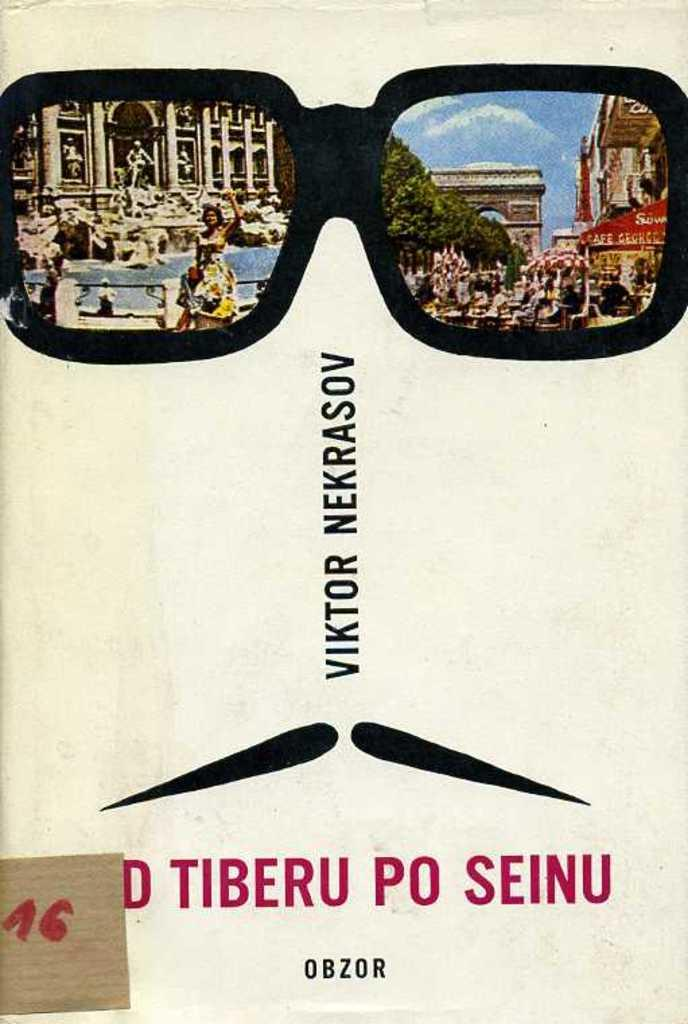Who is the person in the image? Bernard Cribbins is in the image. What type of snow is falling in the image? There is no snow present in the image; it features Bernard Cribbins. What thought is expressed by Bernard Cribbins in the image? The image does not depict any thoughts or expressions from Bernard Cribbins. 